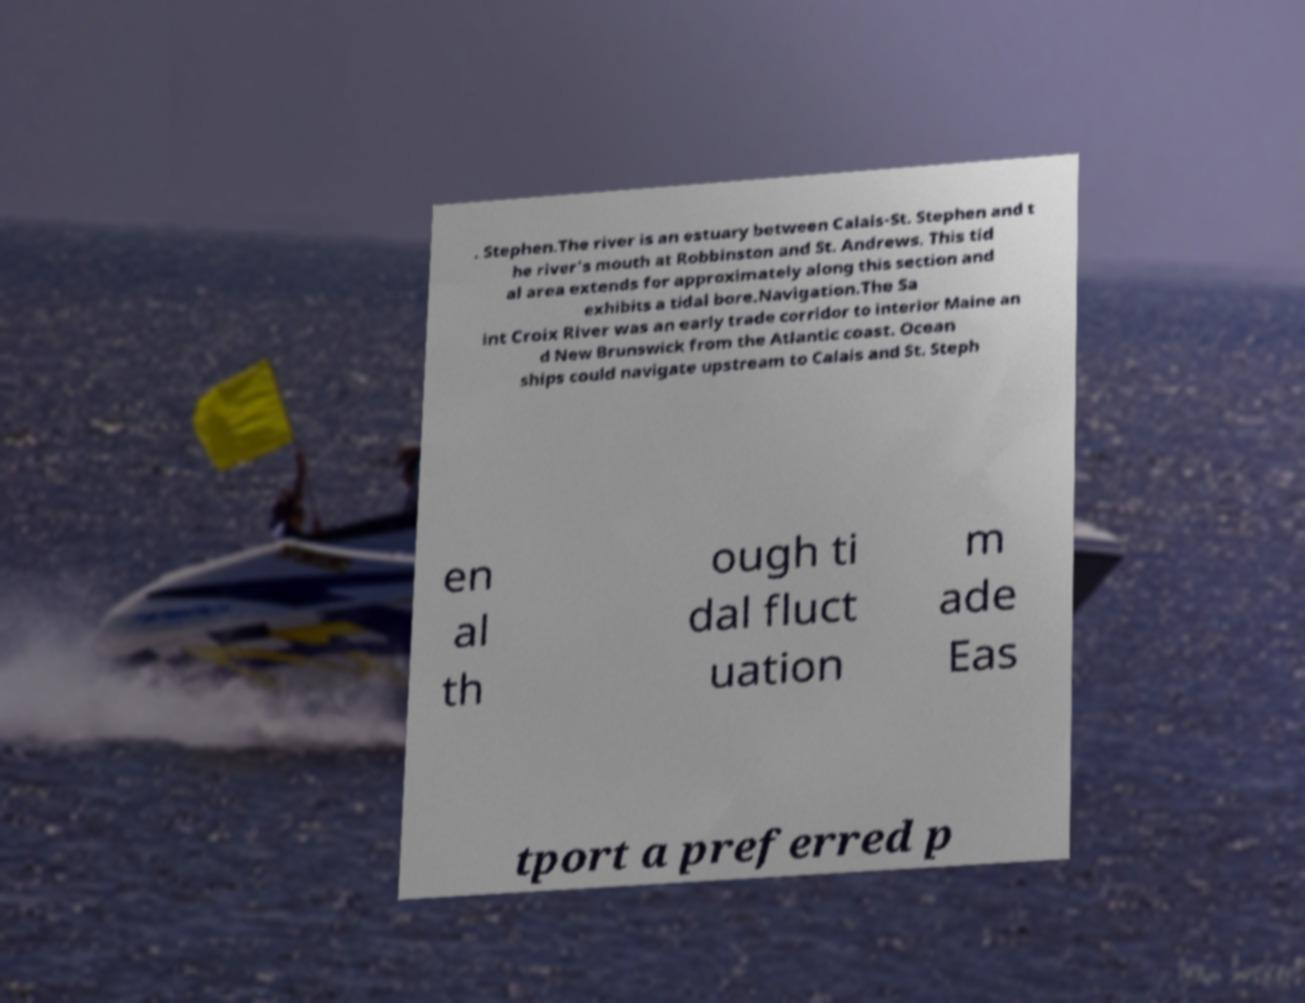Please identify and transcribe the text found in this image. . Stephen.The river is an estuary between Calais-St. Stephen and t he river's mouth at Robbinston and St. Andrews. This tid al area extends for approximately along this section and exhibits a tidal bore.Navigation.The Sa int Croix River was an early trade corridor to interior Maine an d New Brunswick from the Atlantic coast. Ocean ships could navigate upstream to Calais and St. Steph en al th ough ti dal fluct uation m ade Eas tport a preferred p 